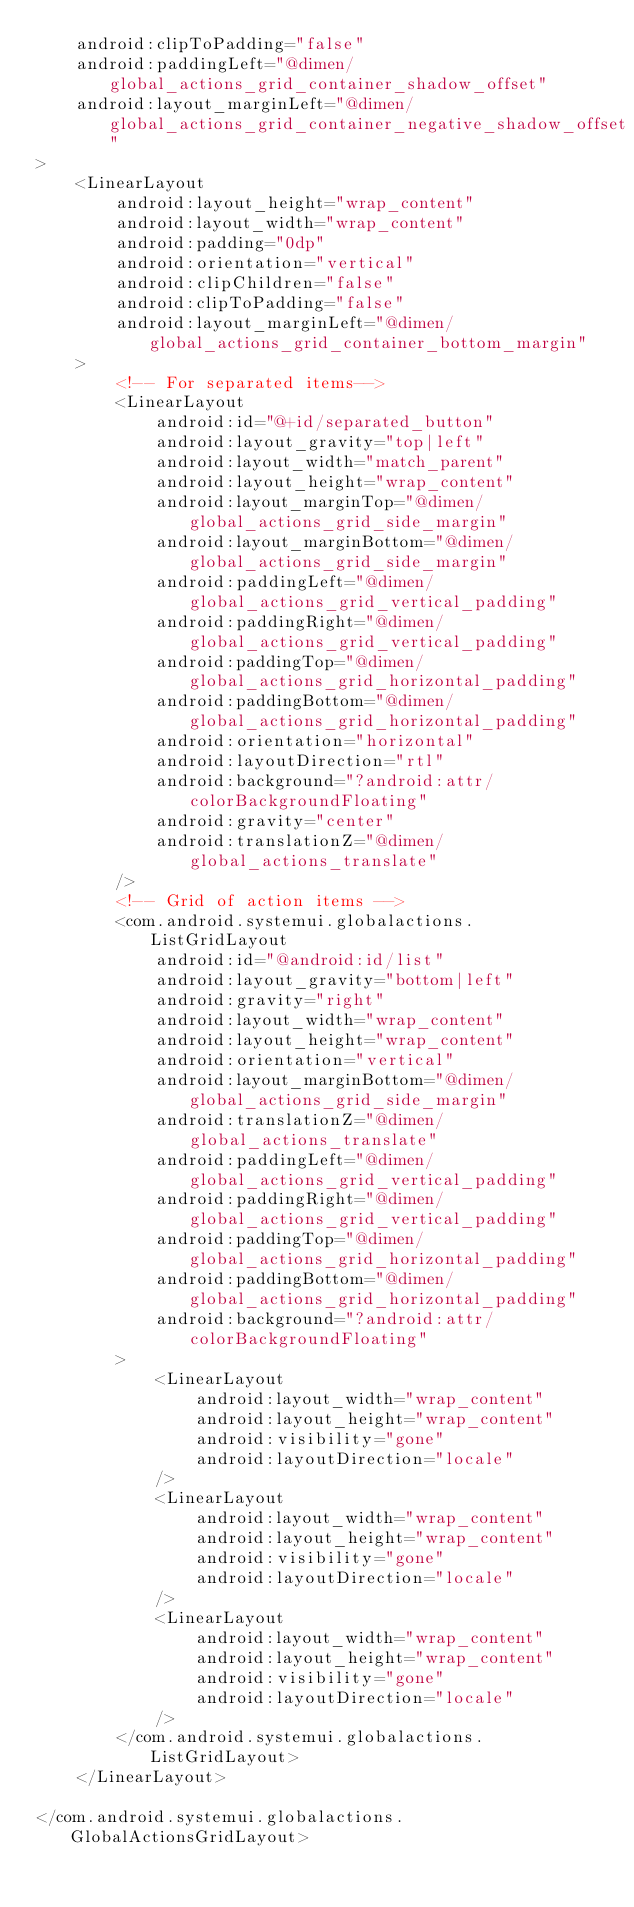<code> <loc_0><loc_0><loc_500><loc_500><_XML_>    android:clipToPadding="false"
    android:paddingLeft="@dimen/global_actions_grid_container_shadow_offset"
    android:layout_marginLeft="@dimen/global_actions_grid_container_negative_shadow_offset"
>
    <LinearLayout
        android:layout_height="wrap_content"
        android:layout_width="wrap_content"
        android:padding="0dp"
        android:orientation="vertical"
        android:clipChildren="false"
        android:clipToPadding="false"
        android:layout_marginLeft="@dimen/global_actions_grid_container_bottom_margin"
    >
        <!-- For separated items-->
        <LinearLayout
            android:id="@+id/separated_button"
            android:layout_gravity="top|left"
            android:layout_width="match_parent"
            android:layout_height="wrap_content"
            android:layout_marginTop="@dimen/global_actions_grid_side_margin"
            android:layout_marginBottom="@dimen/global_actions_grid_side_margin"
            android:paddingLeft="@dimen/global_actions_grid_vertical_padding"
            android:paddingRight="@dimen/global_actions_grid_vertical_padding"
            android:paddingTop="@dimen/global_actions_grid_horizontal_padding"
            android:paddingBottom="@dimen/global_actions_grid_horizontal_padding"
            android:orientation="horizontal"
            android:layoutDirection="rtl"
            android:background="?android:attr/colorBackgroundFloating"
            android:gravity="center"
            android:translationZ="@dimen/global_actions_translate"
        />
        <!-- Grid of action items -->
        <com.android.systemui.globalactions.ListGridLayout
            android:id="@android:id/list"
            android:layout_gravity="bottom|left"
            android:gravity="right"
            android:layout_width="wrap_content"
            android:layout_height="wrap_content"
            android:orientation="vertical"
            android:layout_marginBottom="@dimen/global_actions_grid_side_margin"
            android:translationZ="@dimen/global_actions_translate"
            android:paddingLeft="@dimen/global_actions_grid_vertical_padding"
            android:paddingRight="@dimen/global_actions_grid_vertical_padding"
            android:paddingTop="@dimen/global_actions_grid_horizontal_padding"
            android:paddingBottom="@dimen/global_actions_grid_horizontal_padding"
            android:background="?android:attr/colorBackgroundFloating"
        >
            <LinearLayout
                android:layout_width="wrap_content"
                android:layout_height="wrap_content"
                android:visibility="gone"
                android:layoutDirection="locale"
            />
            <LinearLayout
                android:layout_width="wrap_content"
                android:layout_height="wrap_content"
                android:visibility="gone"
                android:layoutDirection="locale"
            />
            <LinearLayout
                android:layout_width="wrap_content"
                android:layout_height="wrap_content"
                android:visibility="gone"
                android:layoutDirection="locale"
            />
        </com.android.systemui.globalactions.ListGridLayout>
    </LinearLayout>

</com.android.systemui.globalactions.GlobalActionsGridLayout>
</code> 